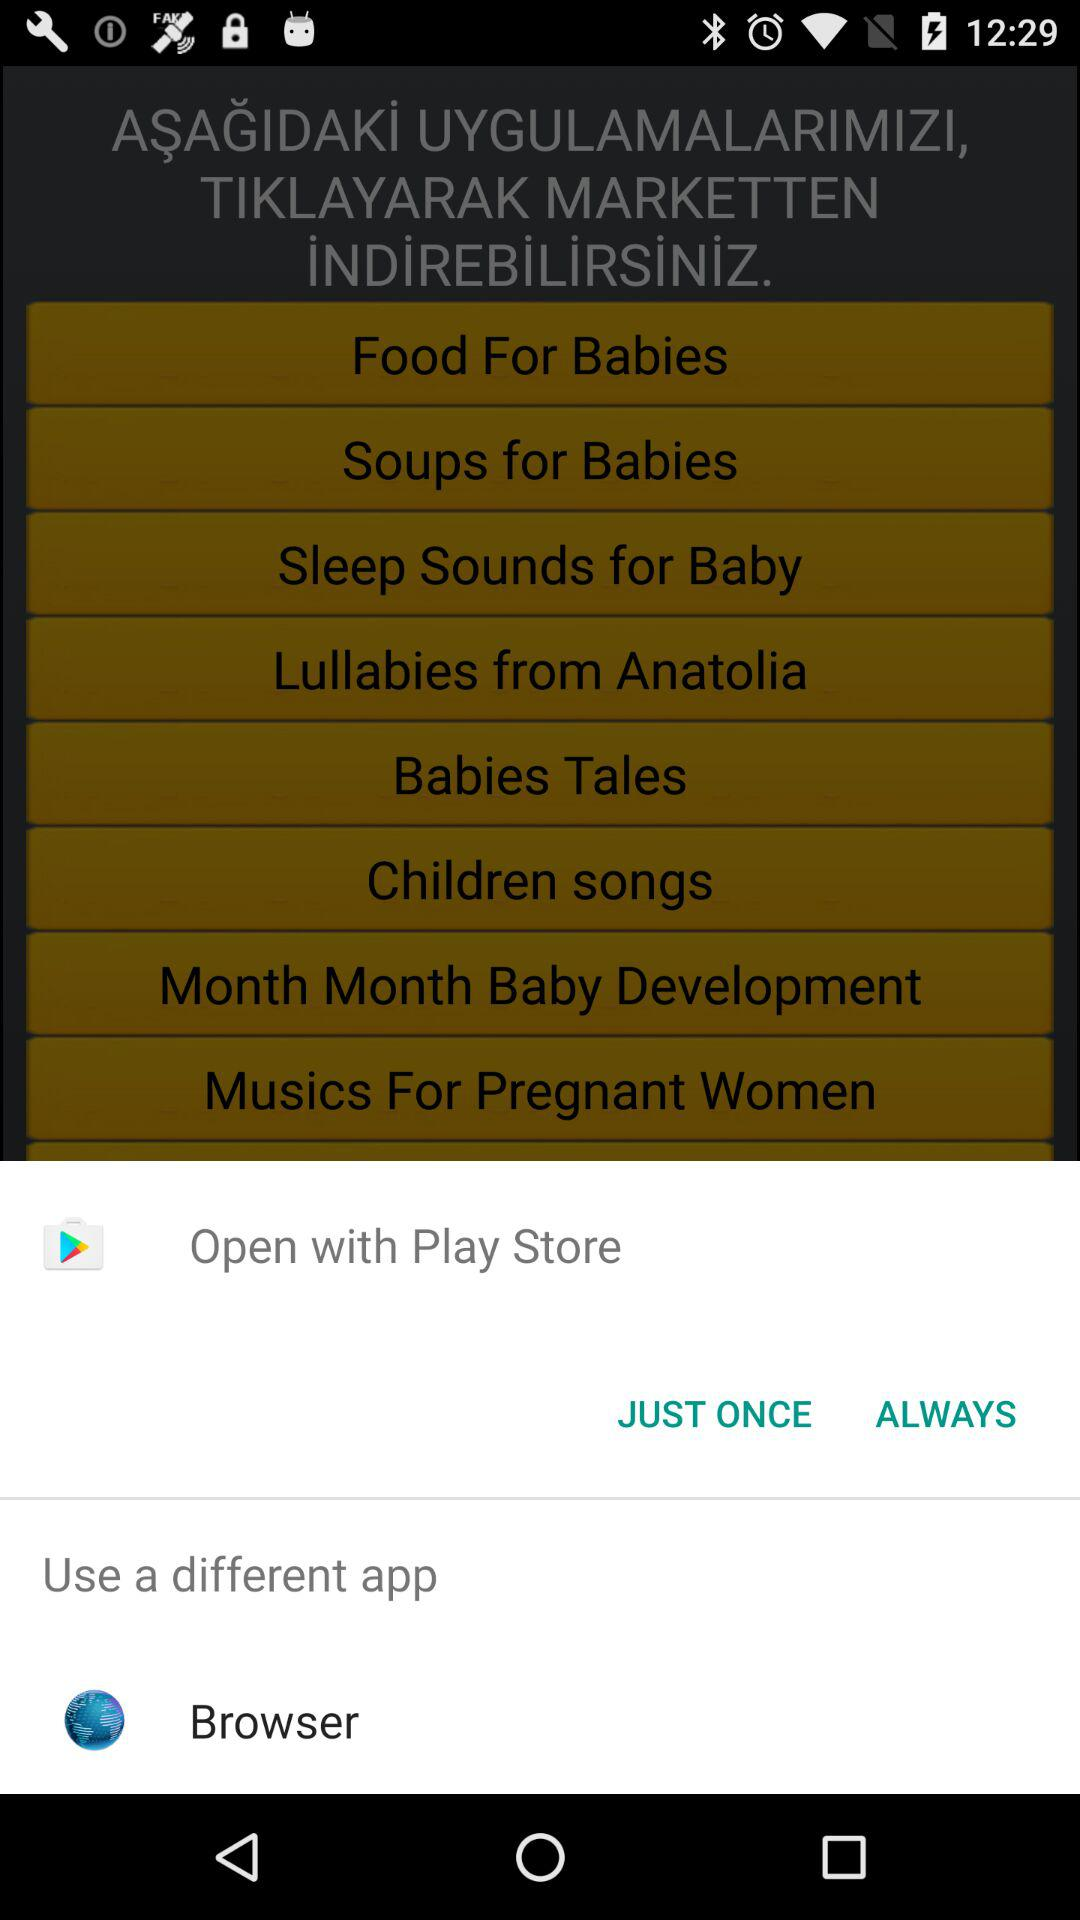What are the different options used to open it? The different options used to open are: "Open with Play Store", and "Browser". 